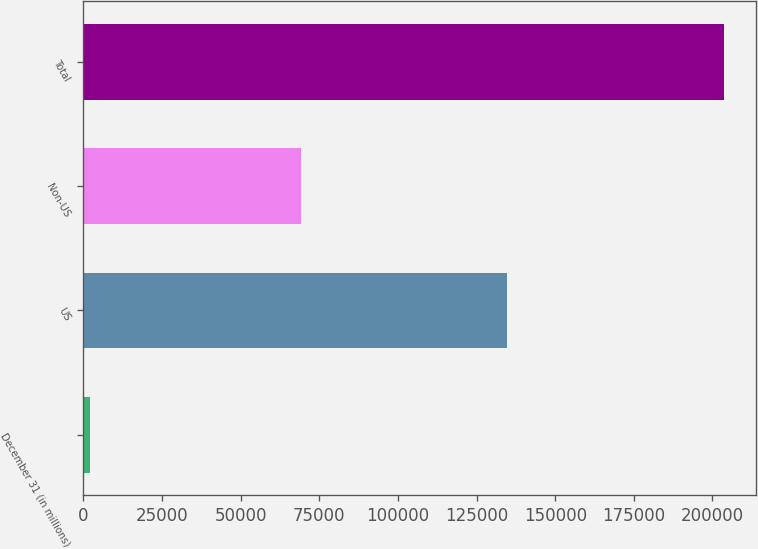<chart> <loc_0><loc_0><loc_500><loc_500><bar_chart><fcel>December 31 (in millions)<fcel>US<fcel>Non-US<fcel>Total<nl><fcel>2007<fcel>134529<fcel>69171<fcel>203700<nl></chart> 